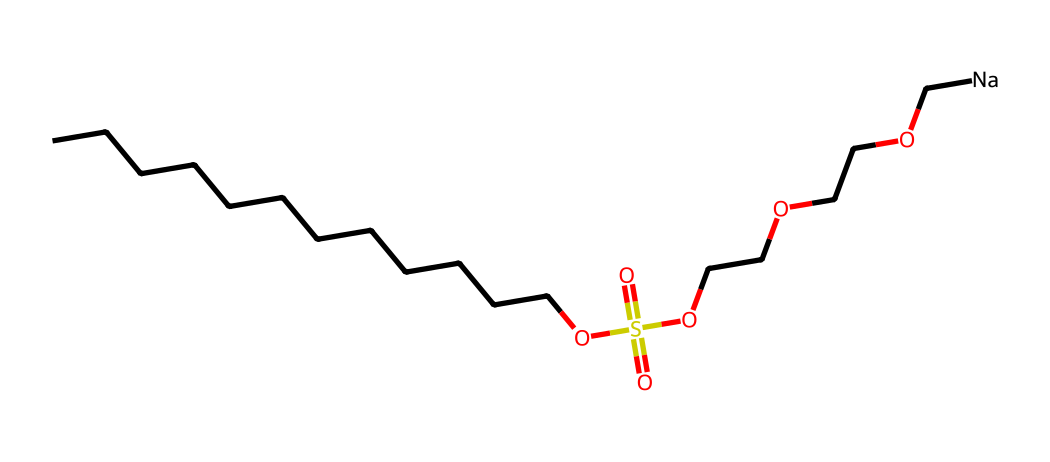What is the total number of carbon atoms in this surfactant? The SMILES notation shows a long hydrocarbon chain (the "CCCCCCCCCCCC" part) which indicates 12 carbon atoms.
Answer: 12 How many oxygen atoms are present in this chemical structure? Analyzing the SMILES, we see there are three distinct groups: the sulfonate (S(=O)(=O)O) and the ethylene glycol (OCCOCCO), each contributing to the oxygen count. The total is 5 oxygen atoms.
Answer: 5 What functional group is responsible for its surfactant properties? The sulfonate group (OS(=O)(=O)O) in the chemical structure is indicative of surfactant properties, providing the hydrophilic part of the molecule.
Answer: sulfonate Does this surfactant have a hydrophobic tail? Yes, the long carbon chain (CCCCCCCCCCCC) serves as the hydrophobic tail that repels water, which is essential for surfactant functionality.
Answer: Yes How many sulfate groups are present in this chemical? The SMILES structure clearly shows one sulfonate (or sulfate-like) group which is indicated by the "OS(=O)(=O)" part.
Answer: 1 What is the charge of this surfactant at physiological pH? In its SMILES representation, the presence of the sodium ion ([Na]) indicates that the surfactant is negatively charged due to the sulfonate group, typical of anionic surfactants.
Answer: negative 